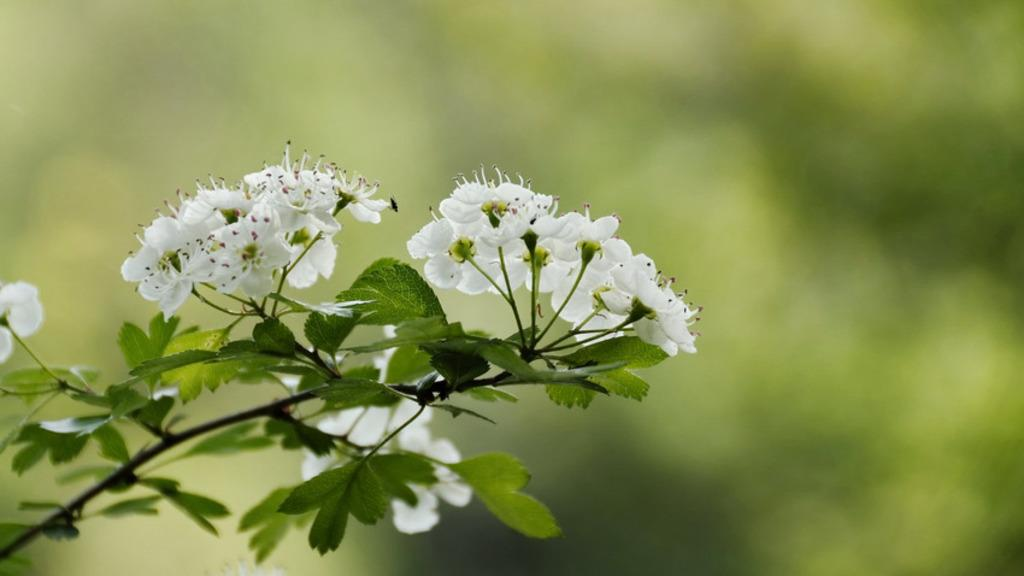What is the main subject of the image? There is a plant in the image. What color are the flowers on the plant? The plant has white flowers. Can you describe the background of the image? The background of the image is blurred. Where is the shop located in the image? There is no shop present in the image; it features a plant with white flowers and a blurred background. How many bikes are visible in the frame of the image? There are no bikes present in the image; it features a plant with white flowers and a blurred background. 